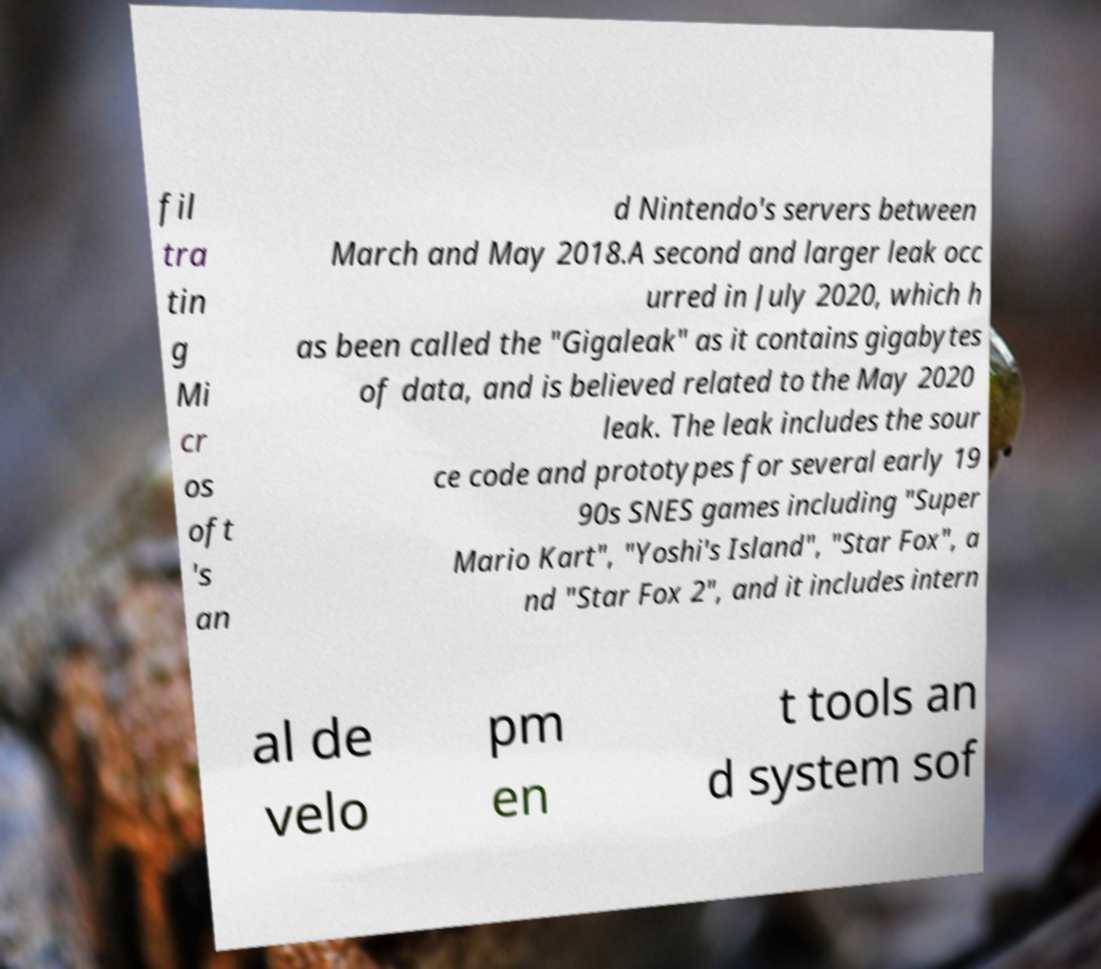Could you extract and type out the text from this image? fil tra tin g Mi cr os oft 's an d Nintendo's servers between March and May 2018.A second and larger leak occ urred in July 2020, which h as been called the "Gigaleak" as it contains gigabytes of data, and is believed related to the May 2020 leak. The leak includes the sour ce code and prototypes for several early 19 90s SNES games including "Super Mario Kart", "Yoshi's Island", "Star Fox", a nd "Star Fox 2", and it includes intern al de velo pm en t tools an d system sof 